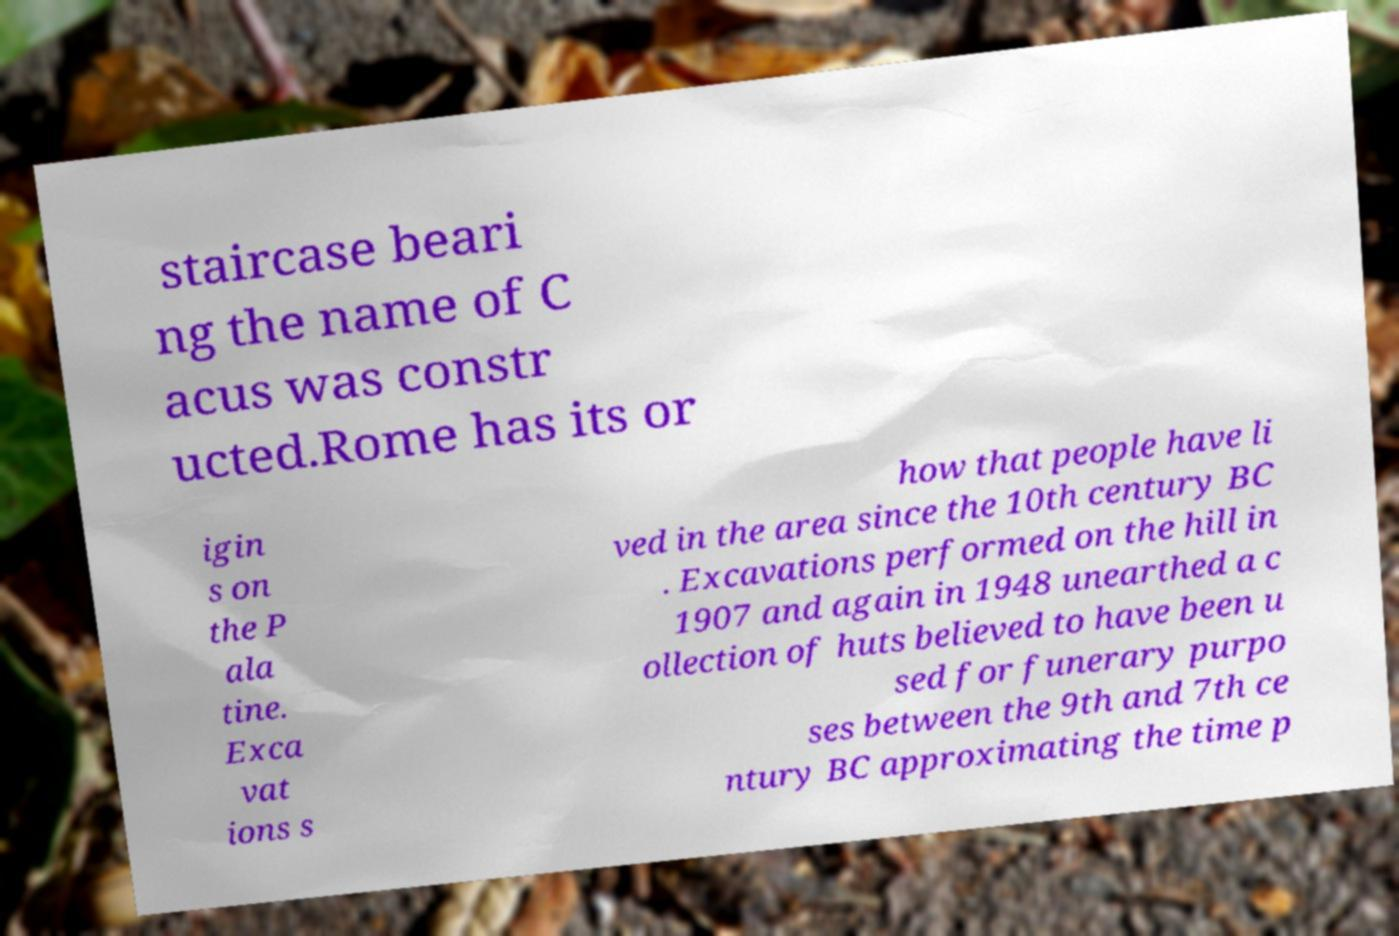Could you assist in decoding the text presented in this image and type it out clearly? staircase beari ng the name of C acus was constr ucted.Rome has its or igin s on the P ala tine. Exca vat ions s how that people have li ved in the area since the 10th century BC . Excavations performed on the hill in 1907 and again in 1948 unearthed a c ollection of huts believed to have been u sed for funerary purpo ses between the 9th and 7th ce ntury BC approximating the time p 